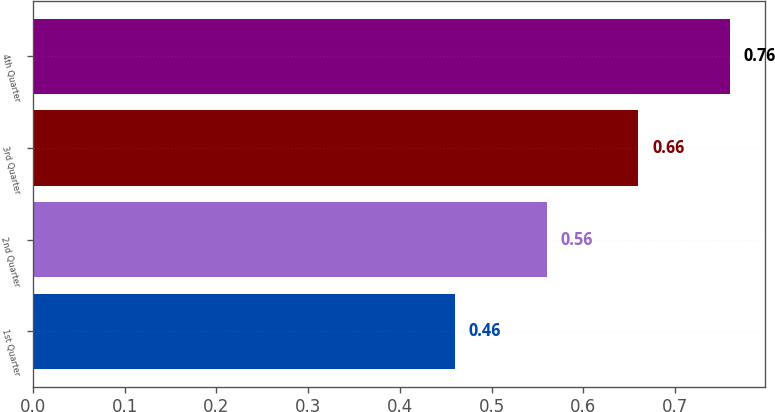Convert chart. <chart><loc_0><loc_0><loc_500><loc_500><bar_chart><fcel>1st Quarter<fcel>2nd Quarter<fcel>3rd Quarter<fcel>4th Quarter<nl><fcel>0.46<fcel>0.56<fcel>0.66<fcel>0.76<nl></chart> 